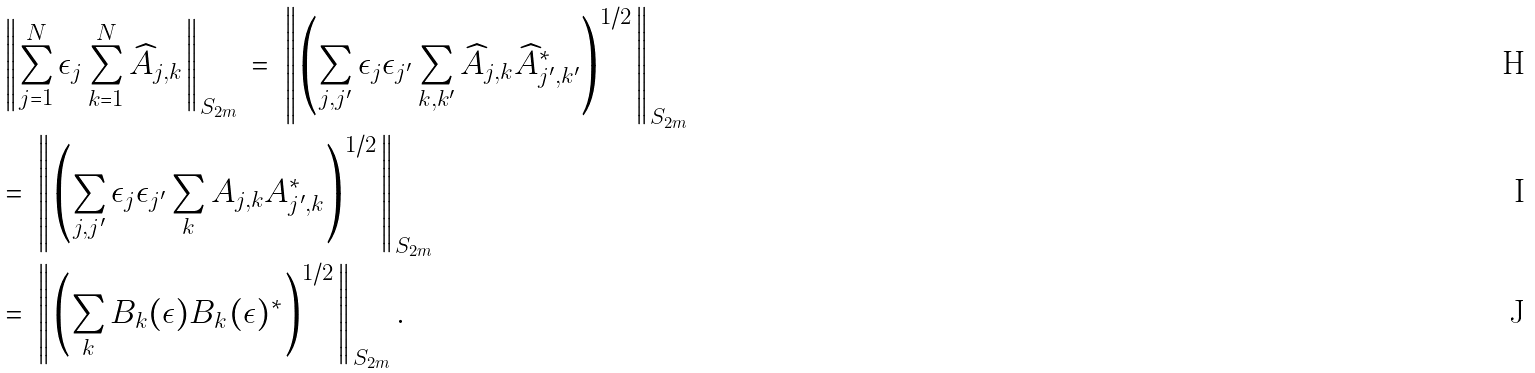Convert formula to latex. <formula><loc_0><loc_0><loc_500><loc_500>& \left \| \sum _ { j = 1 } ^ { N } \epsilon _ { j } \sum _ { k = 1 } ^ { N } \widehat { A } _ { j , k } \right \| _ { S _ { 2 m } } \, = \, \left \| \left ( \sum _ { j , j ^ { \prime } } \epsilon _ { j } \epsilon _ { j ^ { \prime } } \sum _ { k , k ^ { \prime } } \widehat { A } _ { j , k } \widehat { A } _ { j ^ { \prime } , k ^ { \prime } } ^ { * } \right ) ^ { 1 / 2 } \right \| _ { S _ { 2 m } } \\ & = \, \left \| \left ( \sum _ { j , j ^ { \prime } } \epsilon _ { j } \epsilon _ { j ^ { \prime } } \sum _ { k } A _ { j , k } A _ { j ^ { \prime } , k } ^ { * } \right ) ^ { 1 / 2 } \right \| _ { S _ { 2 m } } \\ & = \, \left \| \left ( \sum _ { k } B _ { k } ( \epsilon ) B _ { k } ( \epsilon ) ^ { * } \right ) ^ { 1 / 2 } \right \| _ { S _ { 2 m } } .</formula> 